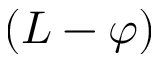<formula> <loc_0><loc_0><loc_500><loc_500>( L - \varphi )</formula> 